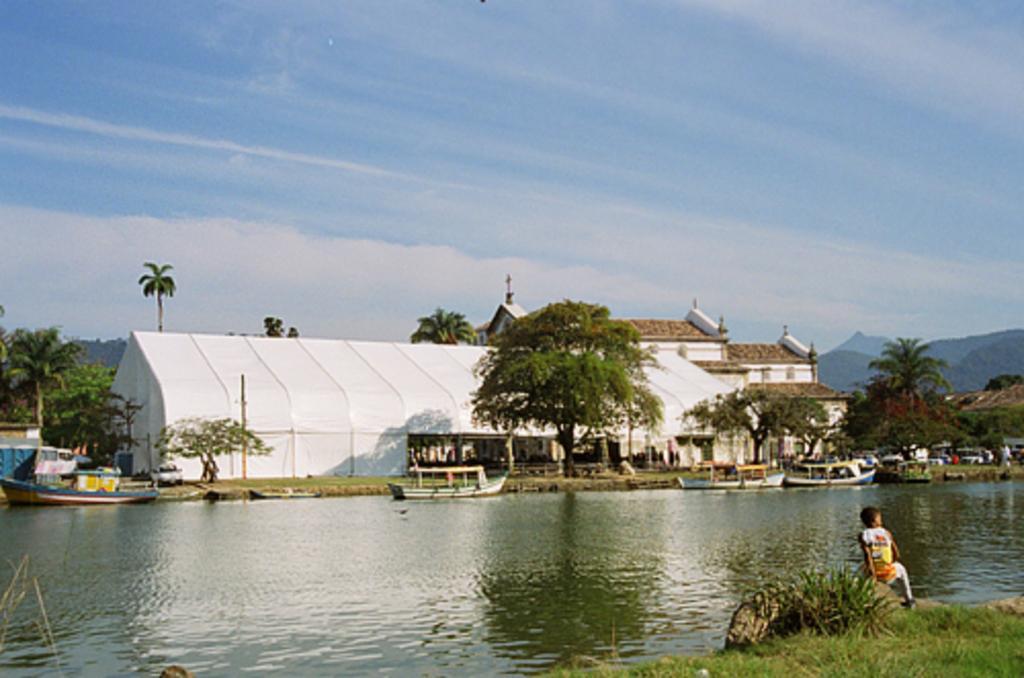In one or two sentences, can you explain what this image depicts? In this picture there is a small boy who is sitting at the bottom side of the image and there is water at the bottom side of the image, there are boats on the water and there are houses, trees and a huge tent in the background area of the image. 